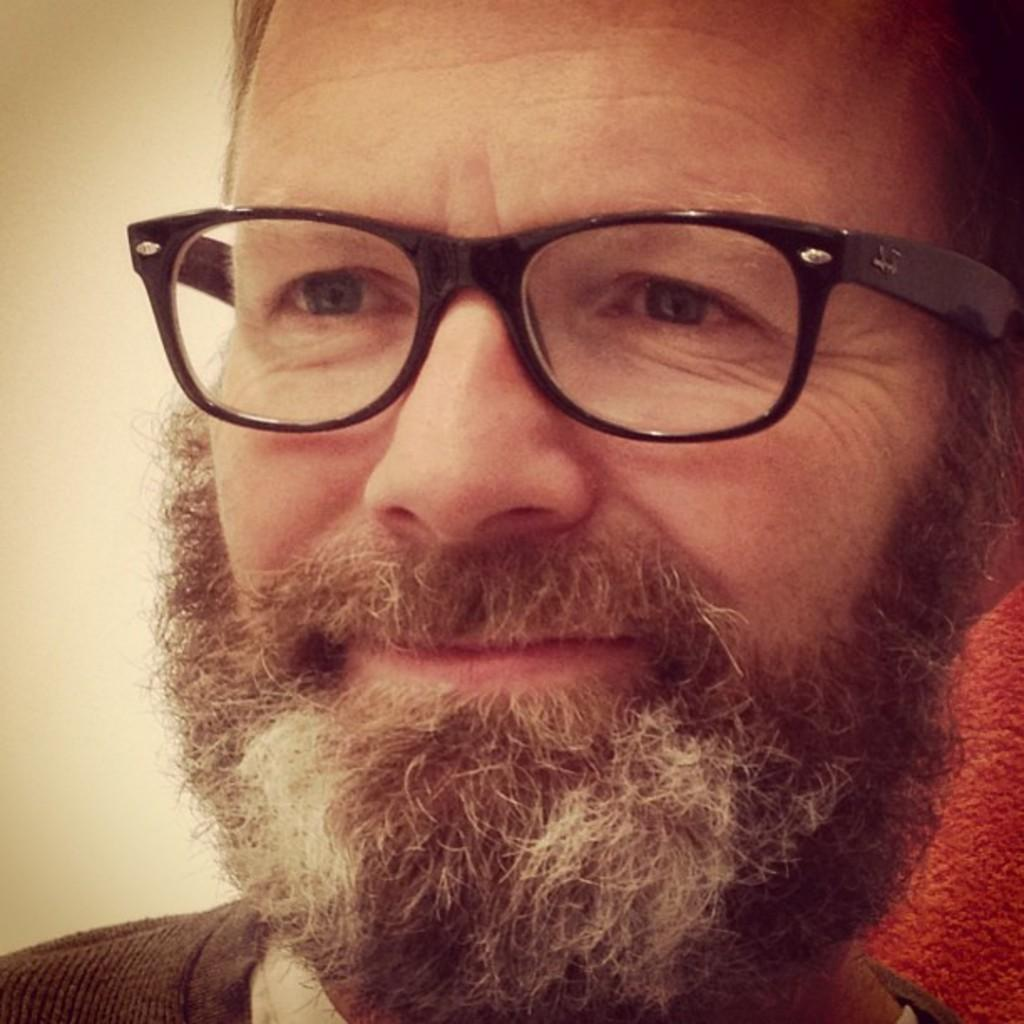What is present in the image? There is a man in the image. Can you describe the man's appearance? The man is wearing spectacles. What degree does the man hold in the image? There is no information about the man's degree in the image. Can you see any beads or stems in the image? There are no beads or stems present in the image. 